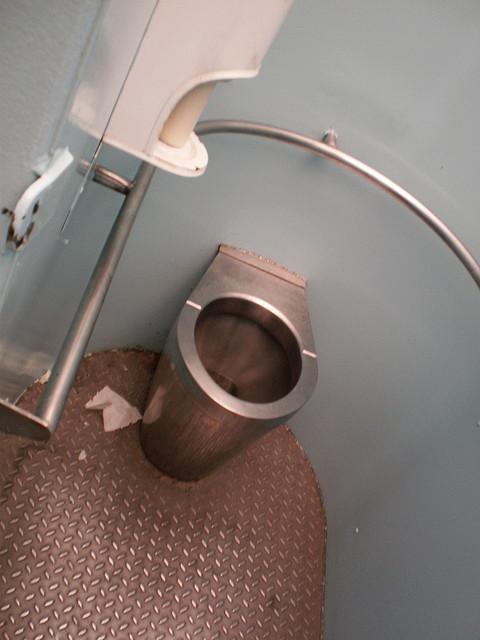What color is the wall?
Write a very short answer. Blue. What kind of room is this?
Short answer required. Bathroom. Is there a toilet in the picture?
Give a very brief answer. Yes. 